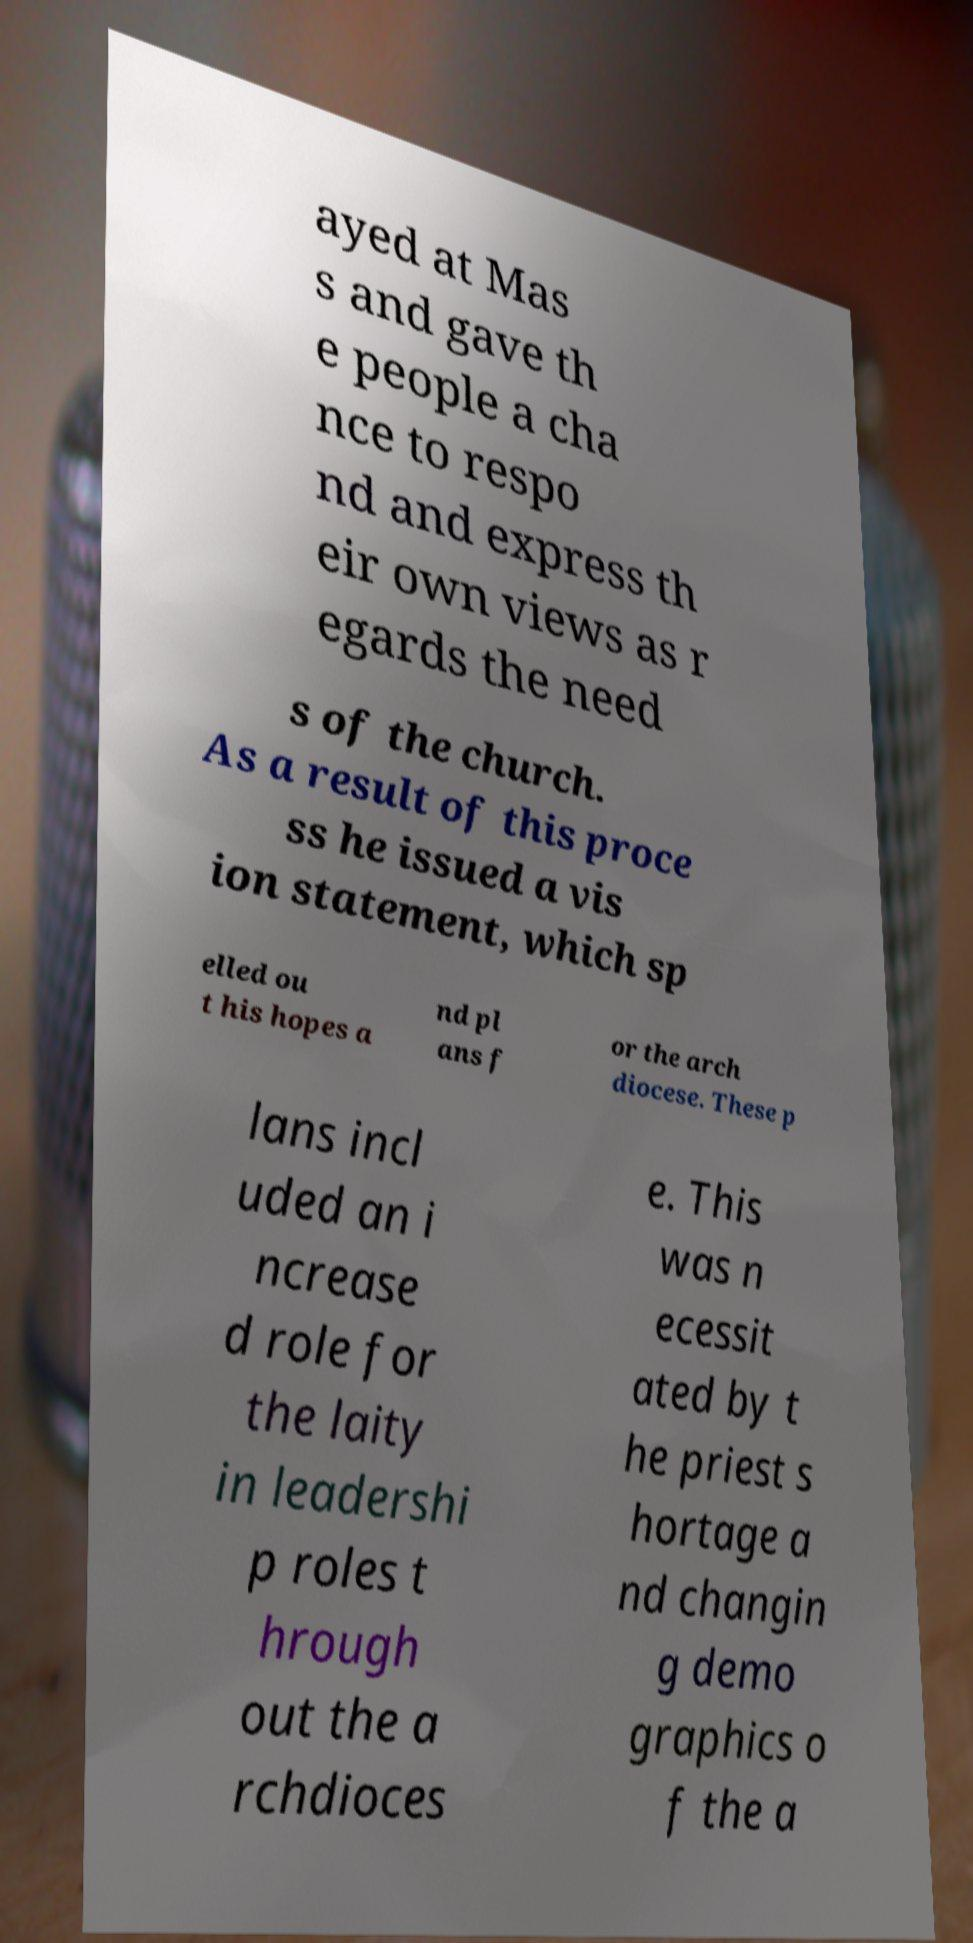I need the written content from this picture converted into text. Can you do that? ayed at Mas s and gave th e people a cha nce to respo nd and express th eir own views as r egards the need s of the church. As a result of this proce ss he issued a vis ion statement, which sp elled ou t his hopes a nd pl ans f or the arch diocese. These p lans incl uded an i ncrease d role for the laity in leadershi p roles t hrough out the a rchdioces e. This was n ecessit ated by t he priest s hortage a nd changin g demo graphics o f the a 